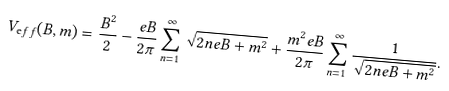<formula> <loc_0><loc_0><loc_500><loc_500>V _ { \mathrm e f f } ( B , m ) = \frac { B ^ { 2 } } { 2 } - \frac { e B } { 2 \pi } \sum _ { n = 1 } ^ { \infty } \sqrt { 2 n e B + m ^ { 2 } } + \frac { m ^ { 2 } e B } { 2 \pi } \sum _ { n = 1 } ^ { \infty } \frac { 1 } { \sqrt { 2 n e B + m ^ { 2 } } } .</formula> 